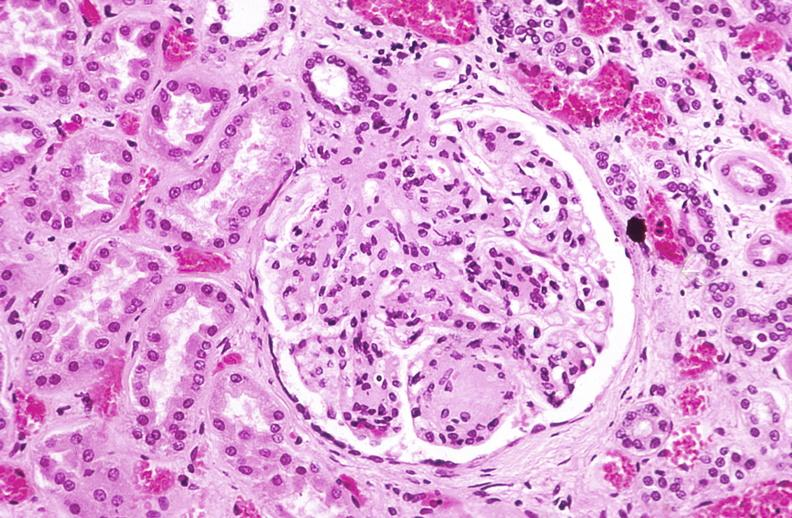what does this image show?
Answer the question using a single word or phrase. Kidney glomerulus 